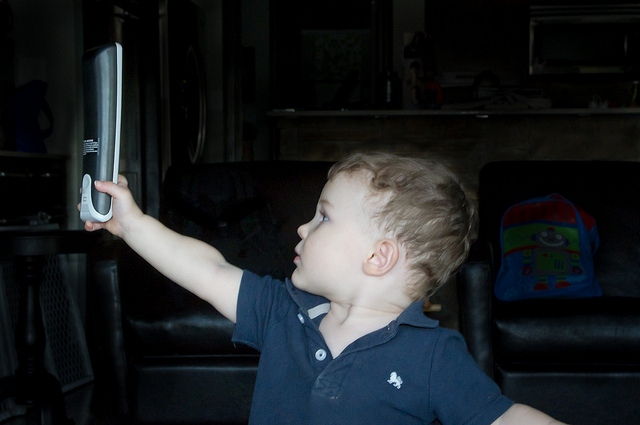<image>What door could he be opening? I don't know which door he could be opening. It could be a garage door, a microwave, fridge, tv, or a refrigerator. What sport is he virtually playing? It is ambiguous what sport he is virtually playing. It could possibly be tennis or basketball. What game are these children playing? I am not sure what game these children are playing. It could be a wii game. What door could he be opening? I am not sure what door he could be opening. It can be the garage door, the microwave, the fridge, the TV, or the refrigerator. What sport is he virtually playing? I don't know what sport he is virtually playing. It can be seen tennis or basketball. What game are these children playing? I am not sure what game these children are playing. It can be seen that they are playing with a Wii console, but I am not sure which game specifically. 